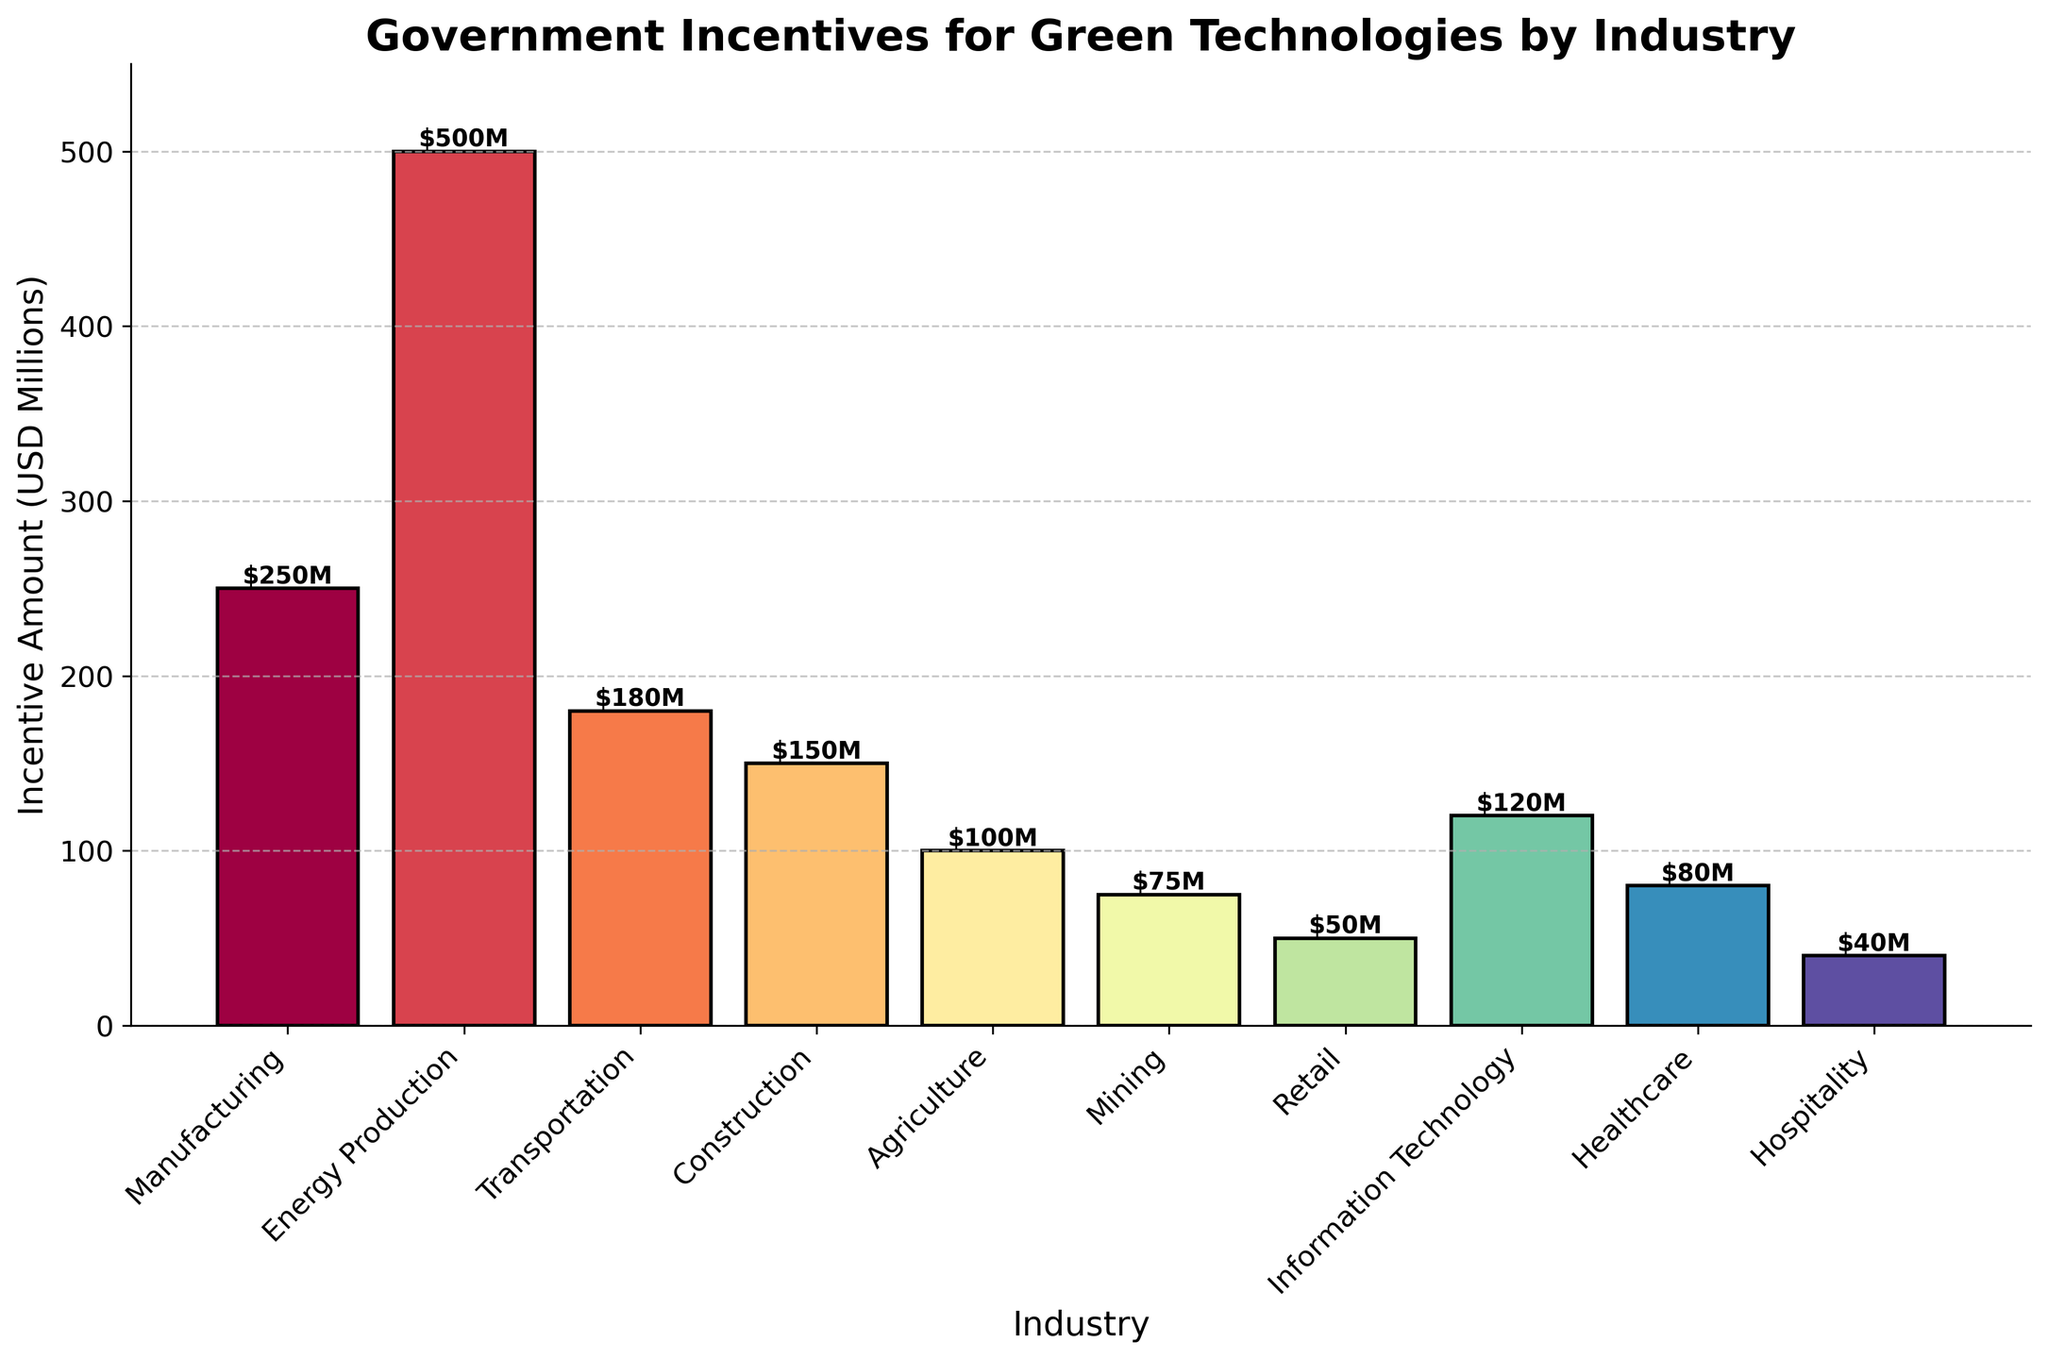What industry receives the highest amount of government incentives? By looking at the heights of the bars, the tallest bar represents the Energy Production industry.
Answer: Energy Production Which two industries receive the least amount of government incentives? The shortest bars on the chart are for the Hospitality and Retail industries.
Answer: Hospitality and Retail How much more incentive does the Manufacturing industry receive compared to the Agriculture industry? The bar for Manufacturing is at $250M, and the bar for Agriculture is at $100M. Subtracting these values: $250M - $100M = $150M.
Answer: $150M What is the combined incentive amount received by the Construction and Healthcare industries? The bar for Construction is at $150M, and the bar for Healthcare is at $80M. Adding these values: $150M + $80M = $230M.
Answer: $230M Which industry receives $120 million in government incentives? By checking the bar labels, the Information Technology industry receives $120M.
Answer: Information Technology What is the average incentive amount across all industries? Summing the incentive amounts: 250 + 500 + 180 + 150 + 100 + 75 + 50 + 120 + 80 + 40 = 1545 millions. There are 10 industries, so the average is 1545/10 = 154.5 million.
Answer: 154.5 million By how much does the incentive amount for the Energy Production industry exceed that of the Mining industry? The bar for Energy Production is at $500M, and the bar for Mining is at $75M. Subtracting these values: $500M - $75M = $425M.
Answer: $425M What is the difference between the highest and lowest incentive amounts across the industries? The highest incentive amount is $500M (Energy Production), and the lowest is $40M (Hospitality). The difference is $500M - $40M = $460M.
Answer: $460M Which industries receive more than $100 million but less than $200 million in incentives? Bars for Transportation ($180M) and Information Technology ($120M) fall within the $100M to $200M range.
Answer: Transportation and Information Technology 